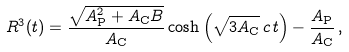Convert formula to latex. <formula><loc_0><loc_0><loc_500><loc_500>R ^ { 3 } ( t ) = \frac { \sqrt { A _ { \text  P}^{2} + A_{\text  C} B}}{A_{\text  C}}        \cosh \left(\sqrt{3 A_{\text  C}} \, c \, t\right)     - \frac{A_{\text  P}}{A_{\text  C}} \, ,</formula> 